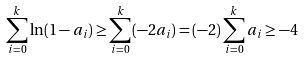<formula> <loc_0><loc_0><loc_500><loc_500>\sum _ { i = 0 } ^ { k } \ln ( 1 - a _ { i } ) \geq \sum _ { i = 0 } ^ { k } ( - 2 a _ { i } ) = ( - 2 ) \sum _ { i = 0 } ^ { k } a _ { i } \geq - 4</formula> 